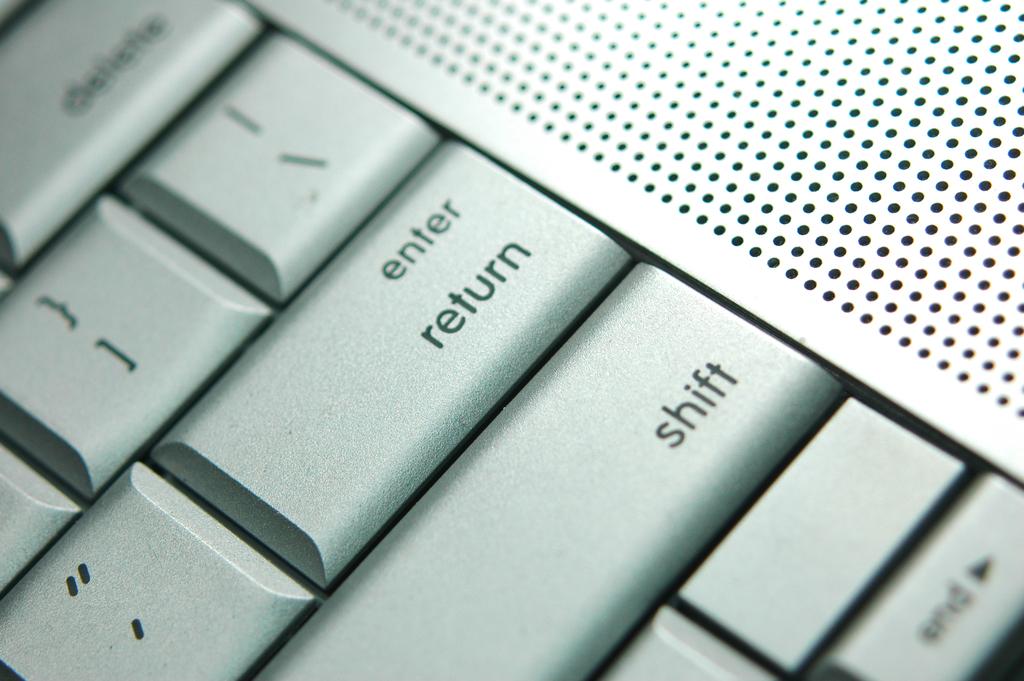On the enter key what does the word below it say?
Your answer should be compact. Return. What key is above the shift key?
Make the answer very short. Return. 